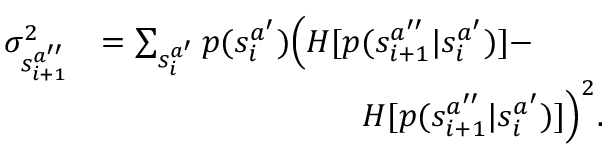<formula> <loc_0><loc_0><loc_500><loc_500>\begin{array} { r l } { \sigma _ { s _ { i + 1 } ^ { a ^ { \prime \prime } } } ^ { 2 } } & { = \sum _ { s _ { i } ^ { a ^ { \prime } } } p ( s _ { i } ^ { a ^ { \prime } } ) \left ( H [ p ( s _ { i + 1 } ^ { a ^ { \prime \prime } } | s _ { i } ^ { a ^ { \prime } } ) ] - } \\ & { \quad H [ p ( s _ { i + 1 } ^ { a ^ { \prime \prime } } | s _ { i } ^ { a ^ { \prime } } ) ] \right ) ^ { 2 } . } \end{array}</formula> 